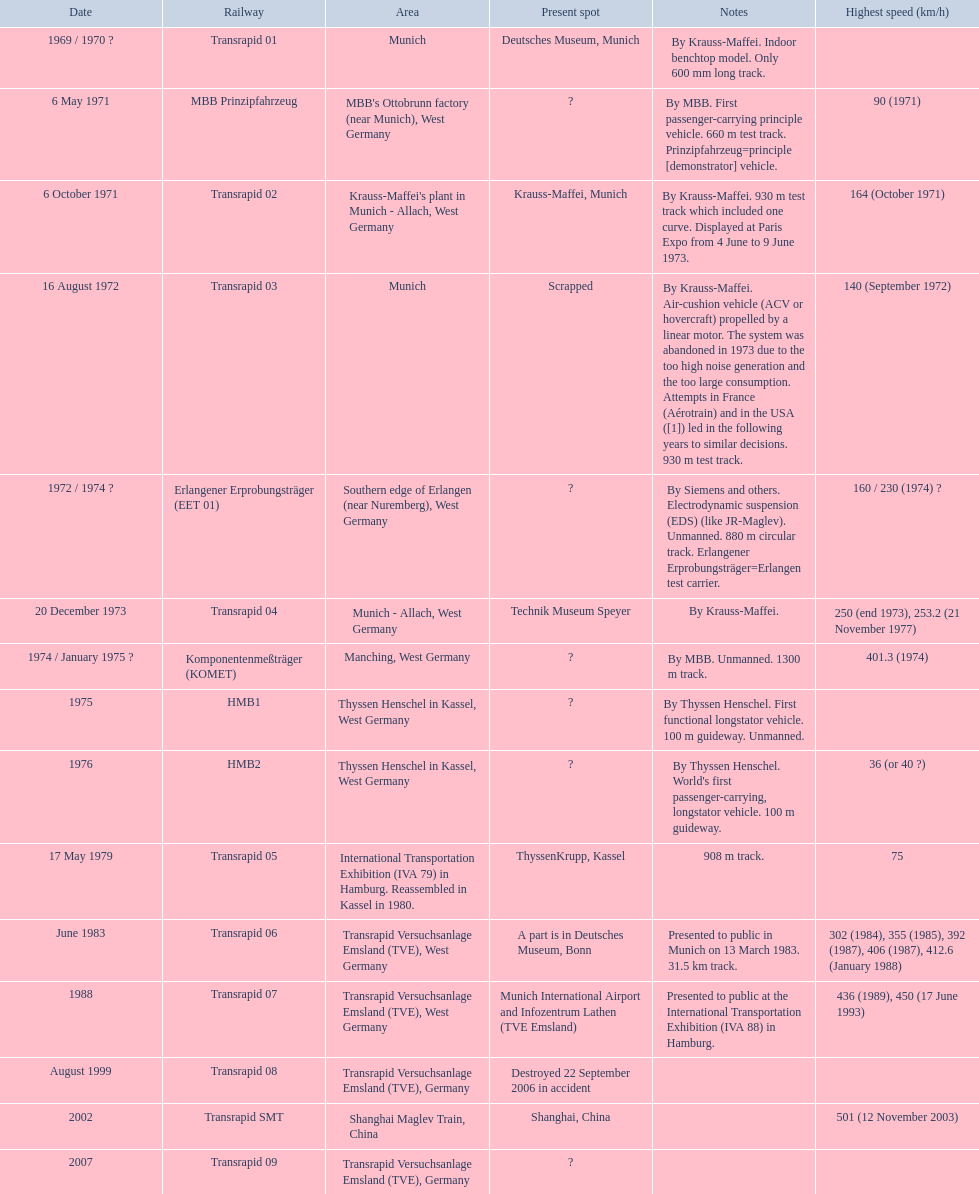What are all trains? Transrapid 01, MBB Prinzipfahrzeug, Transrapid 02, Transrapid 03, Erlangener Erprobungsträger (EET 01), Transrapid 04, Komponentenmeßträger (KOMET), HMB1, HMB2, Transrapid 05, Transrapid 06, Transrapid 07, Transrapid 08, Transrapid SMT, Transrapid 09. Which of all location of trains are known? Deutsches Museum, Munich, Krauss-Maffei, Munich, Scrapped, Technik Museum Speyer, ThyssenKrupp, Kassel, A part is in Deutsches Museum, Bonn, Munich International Airport and Infozentrum Lathen (TVE Emsland), Destroyed 22 September 2006 in accident, Shanghai, China. Which of those trains were scrapped? Transrapid 03. 